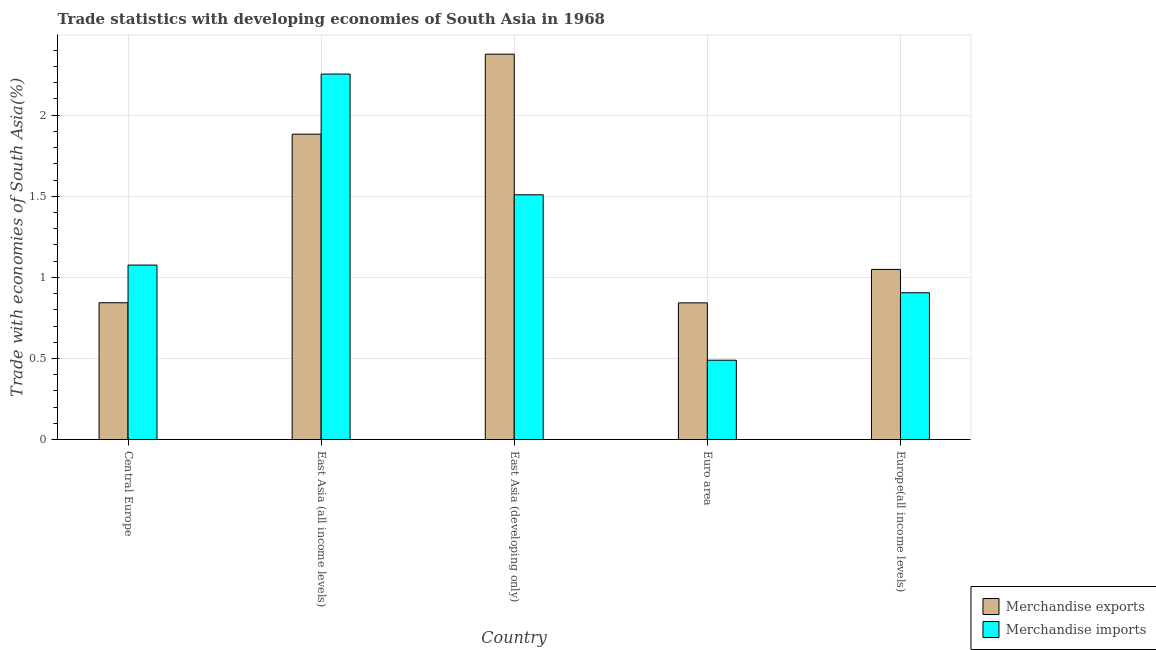How many groups of bars are there?
Your answer should be compact. 5. Are the number of bars per tick equal to the number of legend labels?
Give a very brief answer. Yes. Are the number of bars on each tick of the X-axis equal?
Ensure brevity in your answer.  Yes. How many bars are there on the 1st tick from the left?
Provide a short and direct response. 2. What is the label of the 5th group of bars from the left?
Offer a very short reply. Europe(all income levels). In how many cases, is the number of bars for a given country not equal to the number of legend labels?
Make the answer very short. 0. What is the merchandise exports in Europe(all income levels)?
Give a very brief answer. 1.05. Across all countries, what is the maximum merchandise exports?
Provide a succinct answer. 2.38. Across all countries, what is the minimum merchandise imports?
Provide a succinct answer. 0.49. In which country was the merchandise imports maximum?
Offer a terse response. East Asia (all income levels). What is the total merchandise exports in the graph?
Provide a succinct answer. 6.99. What is the difference between the merchandise exports in East Asia (all income levels) and that in East Asia (developing only)?
Your answer should be compact. -0.49. What is the difference between the merchandise exports in Euro area and the merchandise imports in Europe(all income levels)?
Keep it short and to the point. -0.06. What is the average merchandise imports per country?
Offer a very short reply. 1.25. What is the difference between the merchandise exports and merchandise imports in Europe(all income levels)?
Ensure brevity in your answer.  0.14. What is the ratio of the merchandise exports in Central Europe to that in East Asia (developing only)?
Make the answer very short. 0.35. Is the difference between the merchandise imports in Central Europe and East Asia (developing only) greater than the difference between the merchandise exports in Central Europe and East Asia (developing only)?
Provide a short and direct response. Yes. What is the difference between the highest and the second highest merchandise exports?
Offer a very short reply. 0.49. What is the difference between the highest and the lowest merchandise exports?
Provide a succinct answer. 1.53. How many countries are there in the graph?
Provide a short and direct response. 5. Does the graph contain any zero values?
Offer a terse response. No. Does the graph contain grids?
Keep it short and to the point. Yes. How are the legend labels stacked?
Give a very brief answer. Vertical. What is the title of the graph?
Keep it short and to the point. Trade statistics with developing economies of South Asia in 1968. Does "By country of origin" appear as one of the legend labels in the graph?
Ensure brevity in your answer.  No. What is the label or title of the X-axis?
Make the answer very short. Country. What is the label or title of the Y-axis?
Make the answer very short. Trade with economies of South Asia(%). What is the Trade with economies of South Asia(%) of Merchandise exports in Central Europe?
Provide a short and direct response. 0.84. What is the Trade with economies of South Asia(%) in Merchandise imports in Central Europe?
Ensure brevity in your answer.  1.08. What is the Trade with economies of South Asia(%) of Merchandise exports in East Asia (all income levels)?
Provide a succinct answer. 1.88. What is the Trade with economies of South Asia(%) in Merchandise imports in East Asia (all income levels)?
Keep it short and to the point. 2.25. What is the Trade with economies of South Asia(%) in Merchandise exports in East Asia (developing only)?
Ensure brevity in your answer.  2.38. What is the Trade with economies of South Asia(%) of Merchandise imports in East Asia (developing only)?
Provide a short and direct response. 1.51. What is the Trade with economies of South Asia(%) of Merchandise exports in Euro area?
Provide a succinct answer. 0.84. What is the Trade with economies of South Asia(%) in Merchandise imports in Euro area?
Your answer should be very brief. 0.49. What is the Trade with economies of South Asia(%) in Merchandise exports in Europe(all income levels)?
Offer a terse response. 1.05. What is the Trade with economies of South Asia(%) in Merchandise imports in Europe(all income levels)?
Provide a short and direct response. 0.91. Across all countries, what is the maximum Trade with economies of South Asia(%) of Merchandise exports?
Give a very brief answer. 2.38. Across all countries, what is the maximum Trade with economies of South Asia(%) of Merchandise imports?
Give a very brief answer. 2.25. Across all countries, what is the minimum Trade with economies of South Asia(%) in Merchandise exports?
Your answer should be very brief. 0.84. Across all countries, what is the minimum Trade with economies of South Asia(%) of Merchandise imports?
Keep it short and to the point. 0.49. What is the total Trade with economies of South Asia(%) in Merchandise exports in the graph?
Your response must be concise. 6.99. What is the total Trade with economies of South Asia(%) in Merchandise imports in the graph?
Ensure brevity in your answer.  6.23. What is the difference between the Trade with economies of South Asia(%) in Merchandise exports in Central Europe and that in East Asia (all income levels)?
Make the answer very short. -1.04. What is the difference between the Trade with economies of South Asia(%) of Merchandise imports in Central Europe and that in East Asia (all income levels)?
Give a very brief answer. -1.18. What is the difference between the Trade with economies of South Asia(%) of Merchandise exports in Central Europe and that in East Asia (developing only)?
Offer a terse response. -1.53. What is the difference between the Trade with economies of South Asia(%) in Merchandise imports in Central Europe and that in East Asia (developing only)?
Keep it short and to the point. -0.43. What is the difference between the Trade with economies of South Asia(%) in Merchandise exports in Central Europe and that in Euro area?
Make the answer very short. 0. What is the difference between the Trade with economies of South Asia(%) of Merchandise imports in Central Europe and that in Euro area?
Your response must be concise. 0.59. What is the difference between the Trade with economies of South Asia(%) of Merchandise exports in Central Europe and that in Europe(all income levels)?
Keep it short and to the point. -0.21. What is the difference between the Trade with economies of South Asia(%) in Merchandise imports in Central Europe and that in Europe(all income levels)?
Give a very brief answer. 0.17. What is the difference between the Trade with economies of South Asia(%) of Merchandise exports in East Asia (all income levels) and that in East Asia (developing only)?
Give a very brief answer. -0.49. What is the difference between the Trade with economies of South Asia(%) of Merchandise imports in East Asia (all income levels) and that in East Asia (developing only)?
Give a very brief answer. 0.74. What is the difference between the Trade with economies of South Asia(%) of Merchandise exports in East Asia (all income levels) and that in Euro area?
Ensure brevity in your answer.  1.04. What is the difference between the Trade with economies of South Asia(%) of Merchandise imports in East Asia (all income levels) and that in Euro area?
Make the answer very short. 1.76. What is the difference between the Trade with economies of South Asia(%) of Merchandise exports in East Asia (all income levels) and that in Europe(all income levels)?
Provide a short and direct response. 0.83. What is the difference between the Trade with economies of South Asia(%) of Merchandise imports in East Asia (all income levels) and that in Europe(all income levels)?
Give a very brief answer. 1.35. What is the difference between the Trade with economies of South Asia(%) in Merchandise exports in East Asia (developing only) and that in Euro area?
Your answer should be very brief. 1.53. What is the difference between the Trade with economies of South Asia(%) of Merchandise imports in East Asia (developing only) and that in Euro area?
Your answer should be very brief. 1.02. What is the difference between the Trade with economies of South Asia(%) of Merchandise exports in East Asia (developing only) and that in Europe(all income levels)?
Make the answer very short. 1.33. What is the difference between the Trade with economies of South Asia(%) in Merchandise imports in East Asia (developing only) and that in Europe(all income levels)?
Offer a terse response. 0.6. What is the difference between the Trade with economies of South Asia(%) of Merchandise exports in Euro area and that in Europe(all income levels)?
Provide a short and direct response. -0.21. What is the difference between the Trade with economies of South Asia(%) in Merchandise imports in Euro area and that in Europe(all income levels)?
Your answer should be very brief. -0.42. What is the difference between the Trade with economies of South Asia(%) of Merchandise exports in Central Europe and the Trade with economies of South Asia(%) of Merchandise imports in East Asia (all income levels)?
Provide a short and direct response. -1.41. What is the difference between the Trade with economies of South Asia(%) in Merchandise exports in Central Europe and the Trade with economies of South Asia(%) in Merchandise imports in East Asia (developing only)?
Offer a very short reply. -0.67. What is the difference between the Trade with economies of South Asia(%) of Merchandise exports in Central Europe and the Trade with economies of South Asia(%) of Merchandise imports in Euro area?
Make the answer very short. 0.35. What is the difference between the Trade with economies of South Asia(%) in Merchandise exports in Central Europe and the Trade with economies of South Asia(%) in Merchandise imports in Europe(all income levels)?
Offer a very short reply. -0.06. What is the difference between the Trade with economies of South Asia(%) of Merchandise exports in East Asia (all income levels) and the Trade with economies of South Asia(%) of Merchandise imports in East Asia (developing only)?
Your answer should be compact. 0.37. What is the difference between the Trade with economies of South Asia(%) of Merchandise exports in East Asia (all income levels) and the Trade with economies of South Asia(%) of Merchandise imports in Euro area?
Ensure brevity in your answer.  1.39. What is the difference between the Trade with economies of South Asia(%) in Merchandise exports in East Asia (all income levels) and the Trade with economies of South Asia(%) in Merchandise imports in Europe(all income levels)?
Provide a short and direct response. 0.98. What is the difference between the Trade with economies of South Asia(%) of Merchandise exports in East Asia (developing only) and the Trade with economies of South Asia(%) of Merchandise imports in Euro area?
Offer a very short reply. 1.89. What is the difference between the Trade with economies of South Asia(%) in Merchandise exports in East Asia (developing only) and the Trade with economies of South Asia(%) in Merchandise imports in Europe(all income levels)?
Offer a very short reply. 1.47. What is the difference between the Trade with economies of South Asia(%) in Merchandise exports in Euro area and the Trade with economies of South Asia(%) in Merchandise imports in Europe(all income levels)?
Give a very brief answer. -0.06. What is the average Trade with economies of South Asia(%) of Merchandise exports per country?
Offer a very short reply. 1.4. What is the average Trade with economies of South Asia(%) of Merchandise imports per country?
Make the answer very short. 1.25. What is the difference between the Trade with economies of South Asia(%) of Merchandise exports and Trade with economies of South Asia(%) of Merchandise imports in Central Europe?
Offer a very short reply. -0.23. What is the difference between the Trade with economies of South Asia(%) in Merchandise exports and Trade with economies of South Asia(%) in Merchandise imports in East Asia (all income levels)?
Offer a very short reply. -0.37. What is the difference between the Trade with economies of South Asia(%) in Merchandise exports and Trade with economies of South Asia(%) in Merchandise imports in East Asia (developing only)?
Provide a succinct answer. 0.87. What is the difference between the Trade with economies of South Asia(%) in Merchandise exports and Trade with economies of South Asia(%) in Merchandise imports in Euro area?
Offer a terse response. 0.35. What is the difference between the Trade with economies of South Asia(%) in Merchandise exports and Trade with economies of South Asia(%) in Merchandise imports in Europe(all income levels)?
Your response must be concise. 0.14. What is the ratio of the Trade with economies of South Asia(%) of Merchandise exports in Central Europe to that in East Asia (all income levels)?
Make the answer very short. 0.45. What is the ratio of the Trade with economies of South Asia(%) in Merchandise imports in Central Europe to that in East Asia (all income levels)?
Provide a succinct answer. 0.48. What is the ratio of the Trade with economies of South Asia(%) in Merchandise exports in Central Europe to that in East Asia (developing only)?
Your answer should be compact. 0.35. What is the ratio of the Trade with economies of South Asia(%) of Merchandise imports in Central Europe to that in East Asia (developing only)?
Offer a very short reply. 0.71. What is the ratio of the Trade with economies of South Asia(%) in Merchandise imports in Central Europe to that in Euro area?
Offer a terse response. 2.2. What is the ratio of the Trade with economies of South Asia(%) in Merchandise exports in Central Europe to that in Europe(all income levels)?
Make the answer very short. 0.8. What is the ratio of the Trade with economies of South Asia(%) of Merchandise imports in Central Europe to that in Europe(all income levels)?
Provide a succinct answer. 1.19. What is the ratio of the Trade with economies of South Asia(%) of Merchandise exports in East Asia (all income levels) to that in East Asia (developing only)?
Make the answer very short. 0.79. What is the ratio of the Trade with economies of South Asia(%) of Merchandise imports in East Asia (all income levels) to that in East Asia (developing only)?
Offer a very short reply. 1.49. What is the ratio of the Trade with economies of South Asia(%) of Merchandise exports in East Asia (all income levels) to that in Euro area?
Offer a very short reply. 2.23. What is the ratio of the Trade with economies of South Asia(%) in Merchandise imports in East Asia (all income levels) to that in Euro area?
Your response must be concise. 4.61. What is the ratio of the Trade with economies of South Asia(%) in Merchandise exports in East Asia (all income levels) to that in Europe(all income levels)?
Make the answer very short. 1.79. What is the ratio of the Trade with economies of South Asia(%) of Merchandise imports in East Asia (all income levels) to that in Europe(all income levels)?
Make the answer very short. 2.49. What is the ratio of the Trade with economies of South Asia(%) in Merchandise exports in East Asia (developing only) to that in Euro area?
Provide a succinct answer. 2.82. What is the ratio of the Trade with economies of South Asia(%) in Merchandise imports in East Asia (developing only) to that in Euro area?
Offer a very short reply. 3.09. What is the ratio of the Trade with economies of South Asia(%) in Merchandise exports in East Asia (developing only) to that in Europe(all income levels)?
Make the answer very short. 2.27. What is the ratio of the Trade with economies of South Asia(%) in Merchandise imports in East Asia (developing only) to that in Europe(all income levels)?
Your answer should be very brief. 1.67. What is the ratio of the Trade with economies of South Asia(%) in Merchandise exports in Euro area to that in Europe(all income levels)?
Provide a succinct answer. 0.8. What is the ratio of the Trade with economies of South Asia(%) of Merchandise imports in Euro area to that in Europe(all income levels)?
Offer a terse response. 0.54. What is the difference between the highest and the second highest Trade with economies of South Asia(%) in Merchandise exports?
Offer a very short reply. 0.49. What is the difference between the highest and the second highest Trade with economies of South Asia(%) of Merchandise imports?
Give a very brief answer. 0.74. What is the difference between the highest and the lowest Trade with economies of South Asia(%) in Merchandise exports?
Make the answer very short. 1.53. What is the difference between the highest and the lowest Trade with economies of South Asia(%) in Merchandise imports?
Provide a short and direct response. 1.76. 